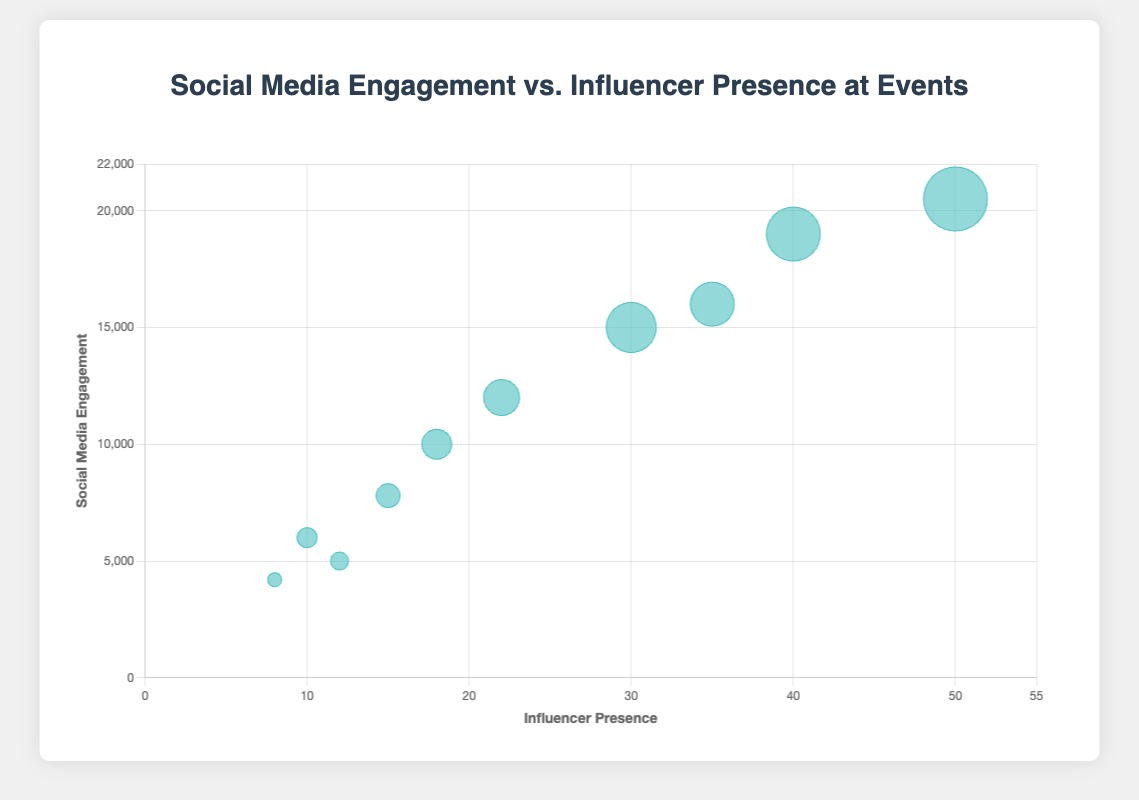What is the title of the chart? The title is usually placed at the top of the chart. Here, it is "Social Media Engagement vs. Influencer Presence at Events".
Answer: Social Media Engagement vs. Influencer Presence at Events How many events are plotted on the chart? Each bubble on the scatter plot represents one event. Counting all the bubbles, you get 10 events.
Answer: 10 Which event has the highest social media engagement? In the scatter plot, the y-axis represents social media engagement. The highest value on the y-axis is 20500, which corresponds to "Fashion Week New York".
Answer: Fashion Week New York Which event uses the most hashtags? The size of each bubble shows the number of hashtags used. The largest bubble corresponds to "Fashion Week New York", which uses 32 hashtags.
Answer: Fashion Week New York Compare the social media engagement between Comic-Con and E3 Expo. Comic-Con has an engagement of 15000 while E3 Expo has 12000. Broadcasting these observed values, Comic-Con has higher social media engagement.
Answer: Comic-Con What is the average influencer presence of all events? Adding up the influencer presence numbers (15 + 30 + 50 + 40 + 22 + 10 + 8 + 35 + 18 + 12) gives 240. Dividing this by 10 events, the average is 240/10 = 24.
Answer: 24 How many events have a social media engagement higher than 10000? Observing the y-axis, the events with engagement higher than 10000 are Comic-Con, Fashion Week New York, SXSW, E3 Expo, and Cannes Film Festival. Counting these, there are 5 events.
Answer: 5 What is the relationship between influencer presence and social media engagement? By observing the scatter plot, bubbles seem to have an upward trend along with the x-axis. This indicates that a higher influencer presence generally results in higher social media engagement.
Answer: Positive correlation Which event has the smallest bubble and what does it signify? The smallest bubble represents "Burning Man" which has 7 hashtags used, indicating it has the least usage of hashtags among the events.
Answer: Burning Man Compare the number of hashtags used between SXSW and Web Summit. SXSW uses 27 hashtags while Web Summit uses 9. Therefore, SXSW uses 18 more hashtags than Web Summit.
Answer: SXSW uses more 